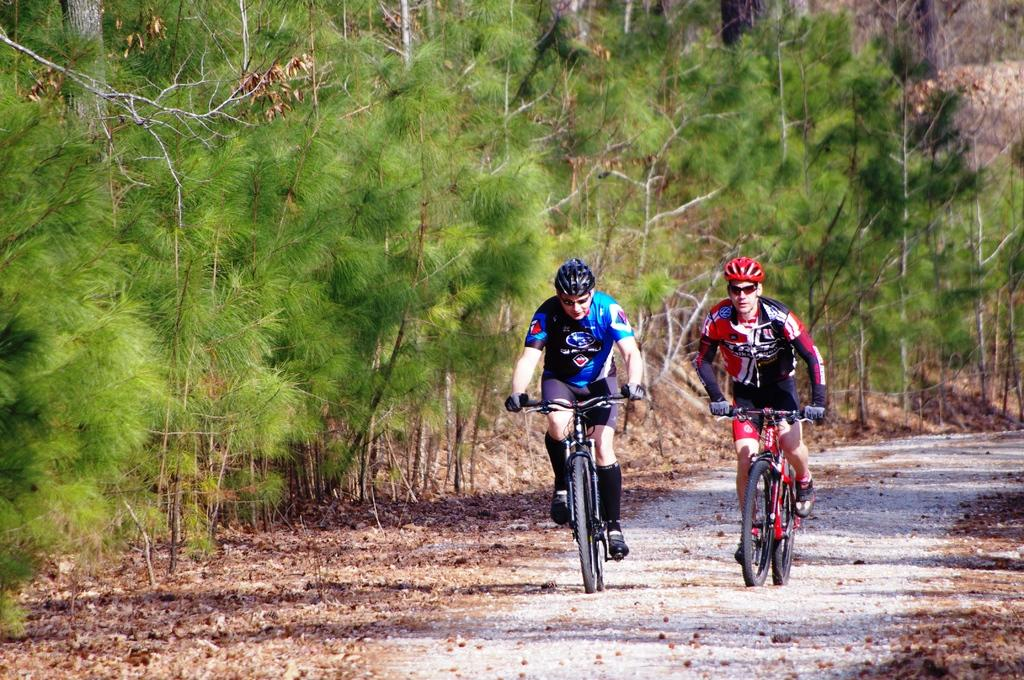How many people are in the image? There are two persons in the image. What are the persons wearing on their heads? Both persons are wearing helmets. What activity are the persons engaged in? The persons are riding bikes. Where are the bikes located? The bikes are on a path. What can be seen in the background of the image? There are trees in the background of the image. What is present on the ground in the image? There are dried leaves on the ground. What type of scissors can be seen cutting the channel in the image? There are no scissors or channels present in the image; it features two persons riding bikes on a path with trees in the background and dried leaves on the ground. 